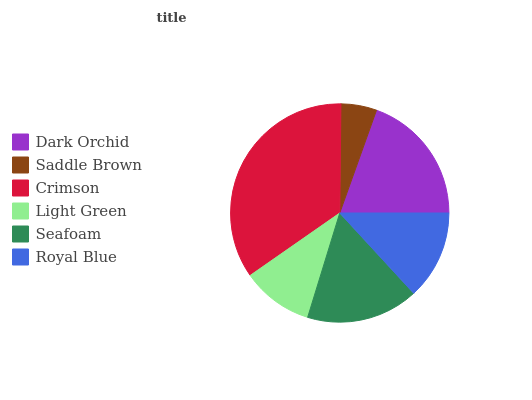Is Saddle Brown the minimum?
Answer yes or no. Yes. Is Crimson the maximum?
Answer yes or no. Yes. Is Crimson the minimum?
Answer yes or no. No. Is Saddle Brown the maximum?
Answer yes or no. No. Is Crimson greater than Saddle Brown?
Answer yes or no. Yes. Is Saddle Brown less than Crimson?
Answer yes or no. Yes. Is Saddle Brown greater than Crimson?
Answer yes or no. No. Is Crimson less than Saddle Brown?
Answer yes or no. No. Is Seafoam the high median?
Answer yes or no. Yes. Is Royal Blue the low median?
Answer yes or no. Yes. Is Light Green the high median?
Answer yes or no. No. Is Dark Orchid the low median?
Answer yes or no. No. 